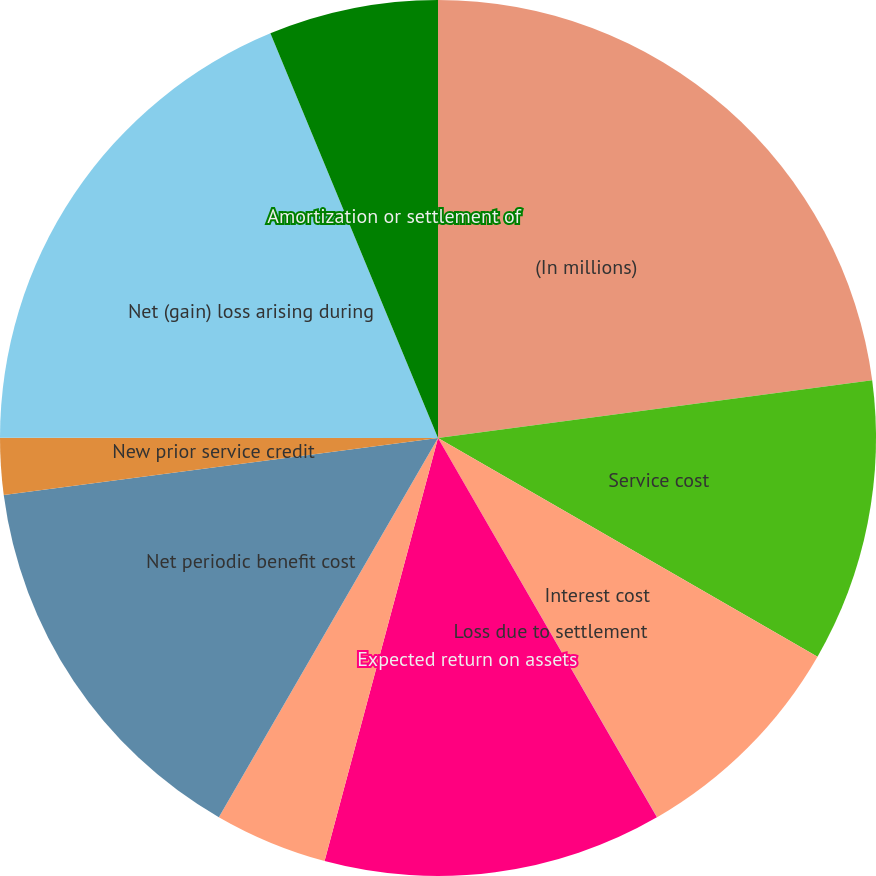<chart> <loc_0><loc_0><loc_500><loc_500><pie_chart><fcel>(In millions)<fcel>Service cost<fcel>Interest cost<fcel>Loss due to settlement<fcel>Expected return on assets<fcel>Recognized actuarial loss<fcel>Net periodic benefit cost<fcel>New prior service credit<fcel>Net (gain) loss arising during<fcel>Amortization or settlement of<nl><fcel>22.9%<fcel>10.42%<fcel>8.34%<fcel>0.01%<fcel>12.5%<fcel>4.17%<fcel>14.58%<fcel>2.09%<fcel>18.74%<fcel>6.25%<nl></chart> 